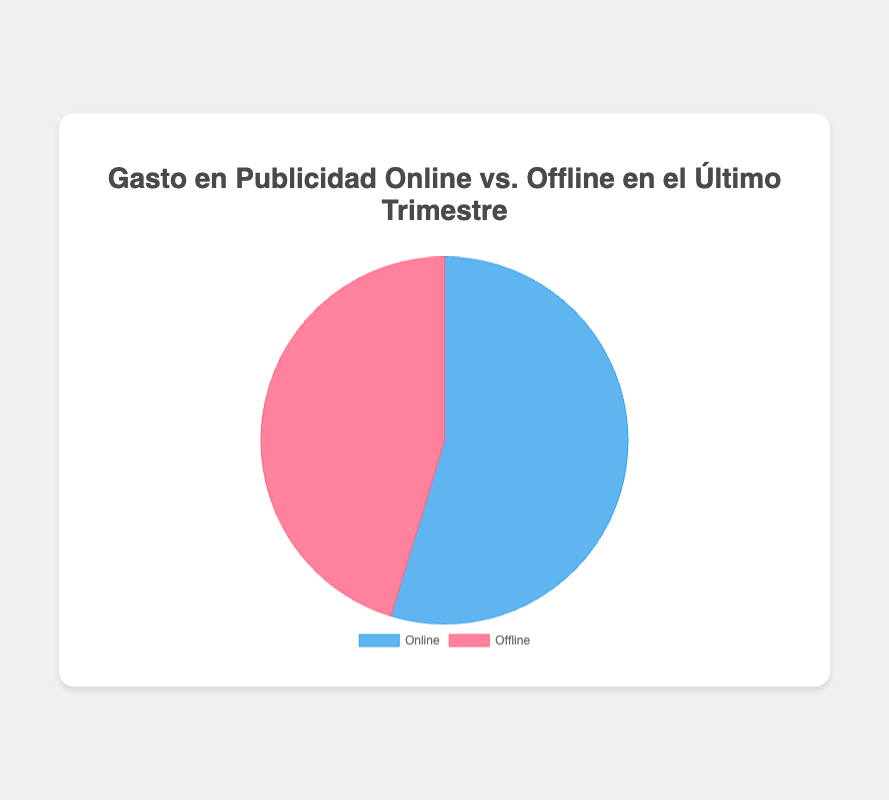What's the total ad spend on online advertising? Sum of all individual spends: 450,000 (Google Ads) + 320,000 (Facebook Ads) + 280,000 (Instagram Ads) + 400,000 (YouTube Ads) = 1,450,000 EUR
Answer: 1,450,000 EUR What's the total ad spend on offline advertising? Sum of all individual spends: 300,000 (Billboards) + 500,000 (TV Commercials) + 180,000 (Radio Ads) + 220,000 (Magazine Ads) = 1,200,000 EUR
Answer: 1,200,000 EUR Which type of advertising had a higher total spend, online or offline? Compare the totals: 1,450,000 EUR (online) vs. 1,200,000 EUR (offline). Online had a higher total spend.
Answer: Online What percentage of the total ad spend was allocated to online advertising? Percentage calculation: (1,450,000 / (1,450,000 + 1,200,000)) * 100 = 54.7%
Answer: 54.7% What percentage of the total ad spend was allocated to offline advertising? Percentage calculation: (1,200,000 / (1,450,000 + 1,200,000)) * 100 = 45.3%
Answer: 45.3% Which sector had a larger share in the pie chart, online or offline advertising? The sector with the higher percentage in the pie chart has a larger share. Online advertising has 54.7%, which is larger than offline advertising's 45.3%.
Answer: Online If we combined the ad spend of YouTube Ads and TV Commercials, what would be the new total for this combined category? Sum of YouTube Ads and TV Commercials: 400,000 (YouTube) + 500,000 (TV Commercials) = 900,000 EUR.
Answer: 900,000 EUR By how much did the online ad spend exceed the offline ad spend? Difference between the two totals: 1,450,000 (online) - 1,200,000 (offline) = 250,000 EUR
Answer: 250,000 EUR If we increased the budget for Magazine Ads by 100,000 EUR, what would be the new total for offline ad spend? New total: 1,200,000 (current offline total) + 100,000 (increase) = 1,300,000 EUR
Answer: 1,300,000 EUR 